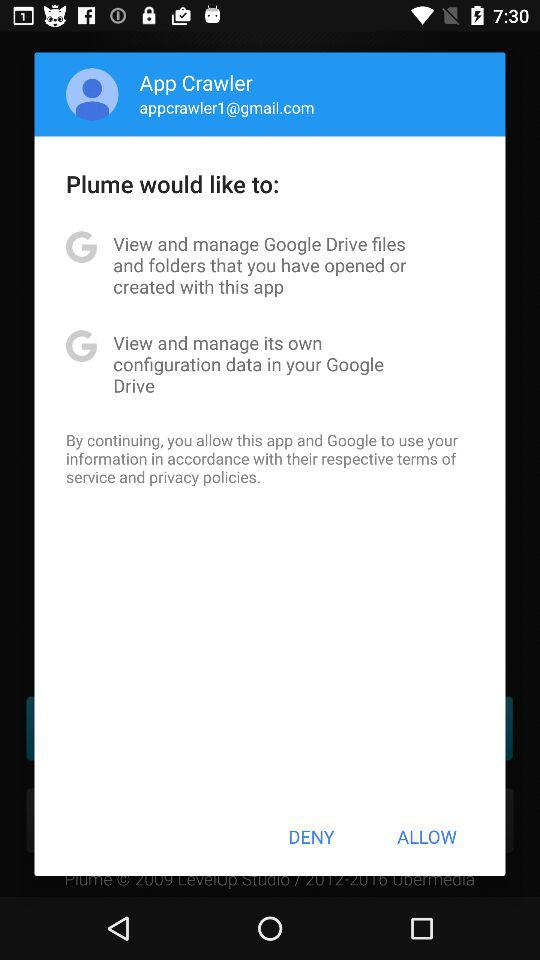How many permissions does Plume want to access?
Answer the question using a single word or phrase. 2 